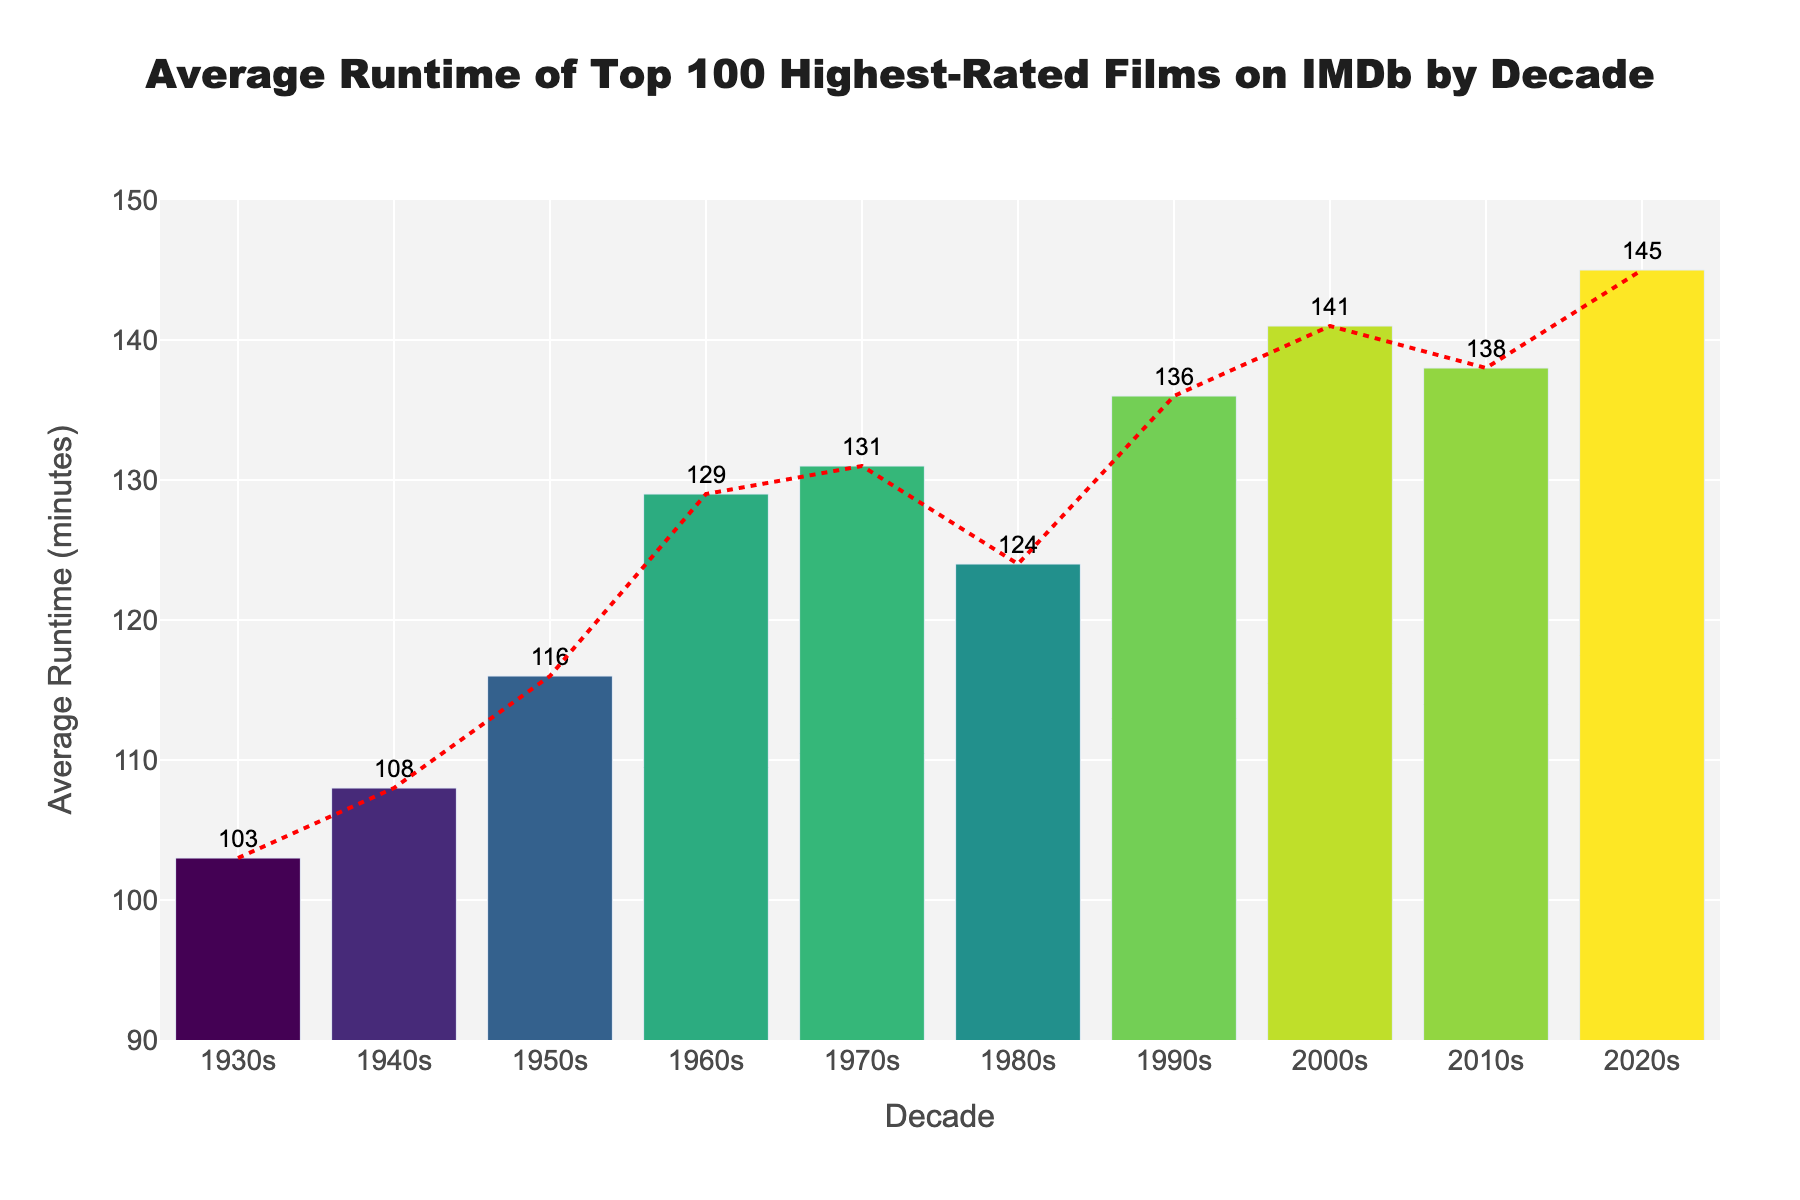what is the average runtime of films in the 1990s? The average runtime for the 1990s can be directly read from the bar chart, which shows 136 minutes for the 1990s.
Answer: 136 minutes When did the trend of increasing runtimes start? By looking at the trend line, we can see that runtimes start increasing notably from the 1950s onwards.
Answer: 1950s How much longer are movies in the 2020s compared to the 1930s? Movies in the 2020s have an average runtime of 145 minutes, while movies in the 1930s have an average runtime of 103 minutes. The difference is 145 - 103 = 42 minutes.
Answer: 42 minutes Which decade has the highest average runtime, and how much is it? By observing the bar heights, the 2020s have the highest average runtime at 145 minutes.
Answer: 2020s with 145 minutes How does the average runtime in the 1980s compare to the 2000s? The bar for the 1980s shows an average runtime of 124 minutes, while the bar for the 2000s indicates an average of 141 minutes. Therefore, movies in the 2000s are 141 - 124 = 17 minutes longer on average.
Answer: 17 minutes longer What is the trend in movie runtime from the 1930s to the 2020s? The overall trend shows a steady increase in average runtime from decade to decade as indicated by the ascending bars and the trend line.
Answer: Increasing Identify the decade with the smallest increase in average runtime compared to its previous decade By comparing consecutive decades, the smallest increase is between the 2010s (138 minutes) and the 2000s (141 minutes), with a difference of 141 - 138 = 3 minutes.
Answer: 2010s What is the percentage increase in average runtime from the 1940s to the 1990s? The average runtime in the 1940s is 108 minutes, and in the 1990s it is 136 minutes. The percentage increase is ((136 - 108) / 108) * 100 = 25.93%.
Answer: 25.93% Which color represents the bar for the 1970s? The colored continuum uses the 'Viridis' color scale. By observing the chart, the color seems to be greenish, which fits within the color range for a value around 131 minutes.
Answer: Greenish color Are there any decades where the average runtime decrease compared to the previous decade? By examining the bars sequentially from the 1930s to the 2020s, we can see that there is no decade where the average runtime decreases, only increases.
Answer: No 